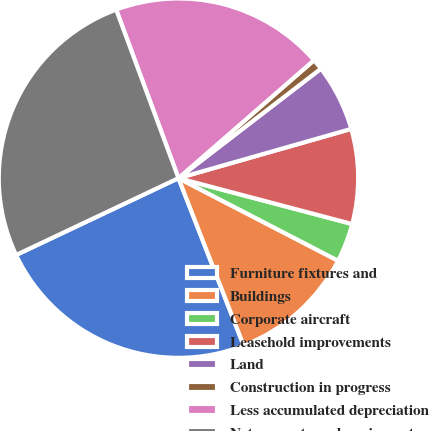Convert chart to OTSL. <chart><loc_0><loc_0><loc_500><loc_500><pie_chart><fcel>Furniture fixtures and<fcel>Buildings<fcel>Corporate aircraft<fcel>Leasehold improvements<fcel>Land<fcel>Construction in progress<fcel>Less accumulated depreciation<fcel>Net property and equipment<nl><fcel>23.88%<fcel>11.49%<fcel>3.49%<fcel>8.53%<fcel>6.01%<fcel>0.97%<fcel>19.24%<fcel>26.4%<nl></chart> 